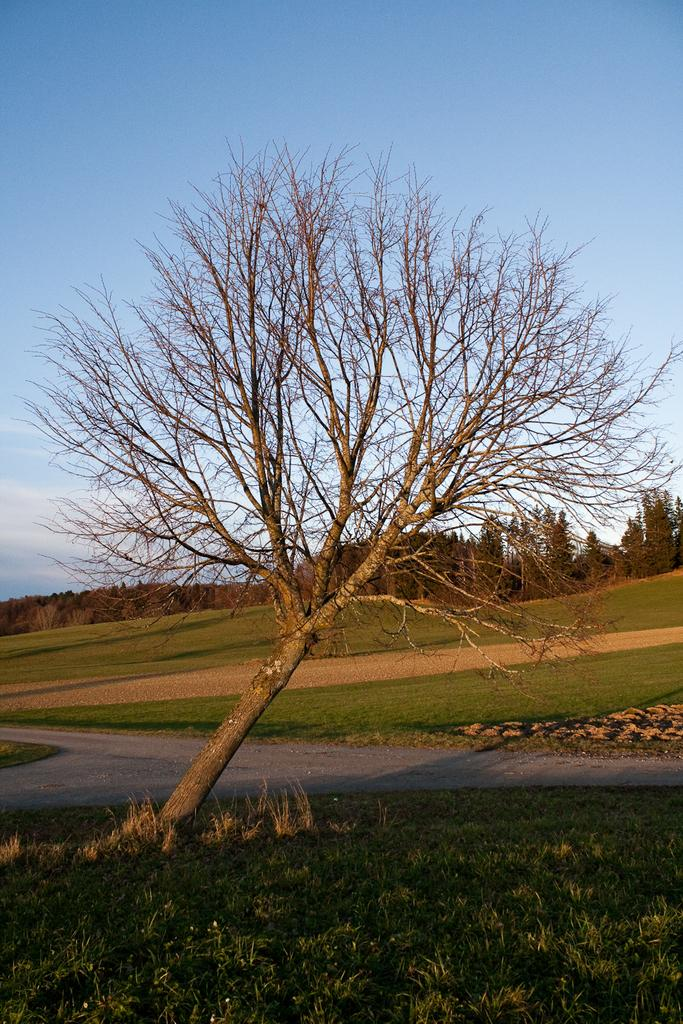What type of tree is in the image? There is a dried tree in the image. What can be seen in the background of the image? The background of the image includes grass and trees with green color. What is visible in the sky in the image? The sky is visible in the image with blue and white colors. What type of breakfast is being served on the tree in the image? There is no breakfast or any food item present in the image; it only features a dried tree and the surrounding environment. 